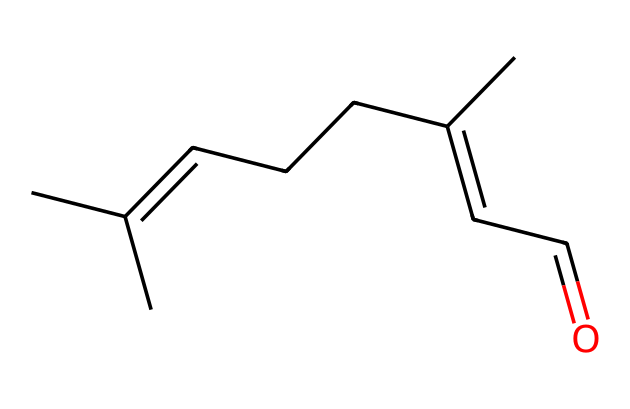How many carbon atoms are in citral? The SMILES representation reveals that there are several "C" symbols, each representing a carbon atom. Counting these gives a total of 10 carbon atoms in the structure.
Answer: 10 What is the functional group present in citral? In the SMILES notation, the "C=O" at the end indicates the presence of a carbonyl group, which is characteristic of aldehydes. Therefore, the functional group is an aldehyde.
Answer: aldehyde What is the degree of unsaturation in citral? The degree of unsaturation can be calculated by examining the number of rings and double bonds. In this case, there are two double bonds (as indicated by the "C=C") and no rings, leading to a degree of unsaturation of 2.
Answer: 2 What type of chemical is citral classified as? Citral is classified as a monoterpene, based on its structure and its occurrence in natural products like lemongrass essential oil.
Answer: monoterpene What aroma characteristic does citral contribute? Citral is known for its citrus aroma, often associated with lemon and lemongrass scents, which provides a fresh and zesty fragrance.
Answer: citrus How many hydrogen atoms are in citral? By analyzing the structure derived from the SMILES notation and knowing the bonding rules of carbon, it can be seen that there are 16 hydrogen atoms connected to the carbon skeleton of citral.
Answer: 16 Does citral have any chiral centers? Upon examining the carbon atoms in the structure, it can be determined that there are no carbon atoms bonded to four different substituents, indicating that citral does not have any chiral centers.
Answer: no 